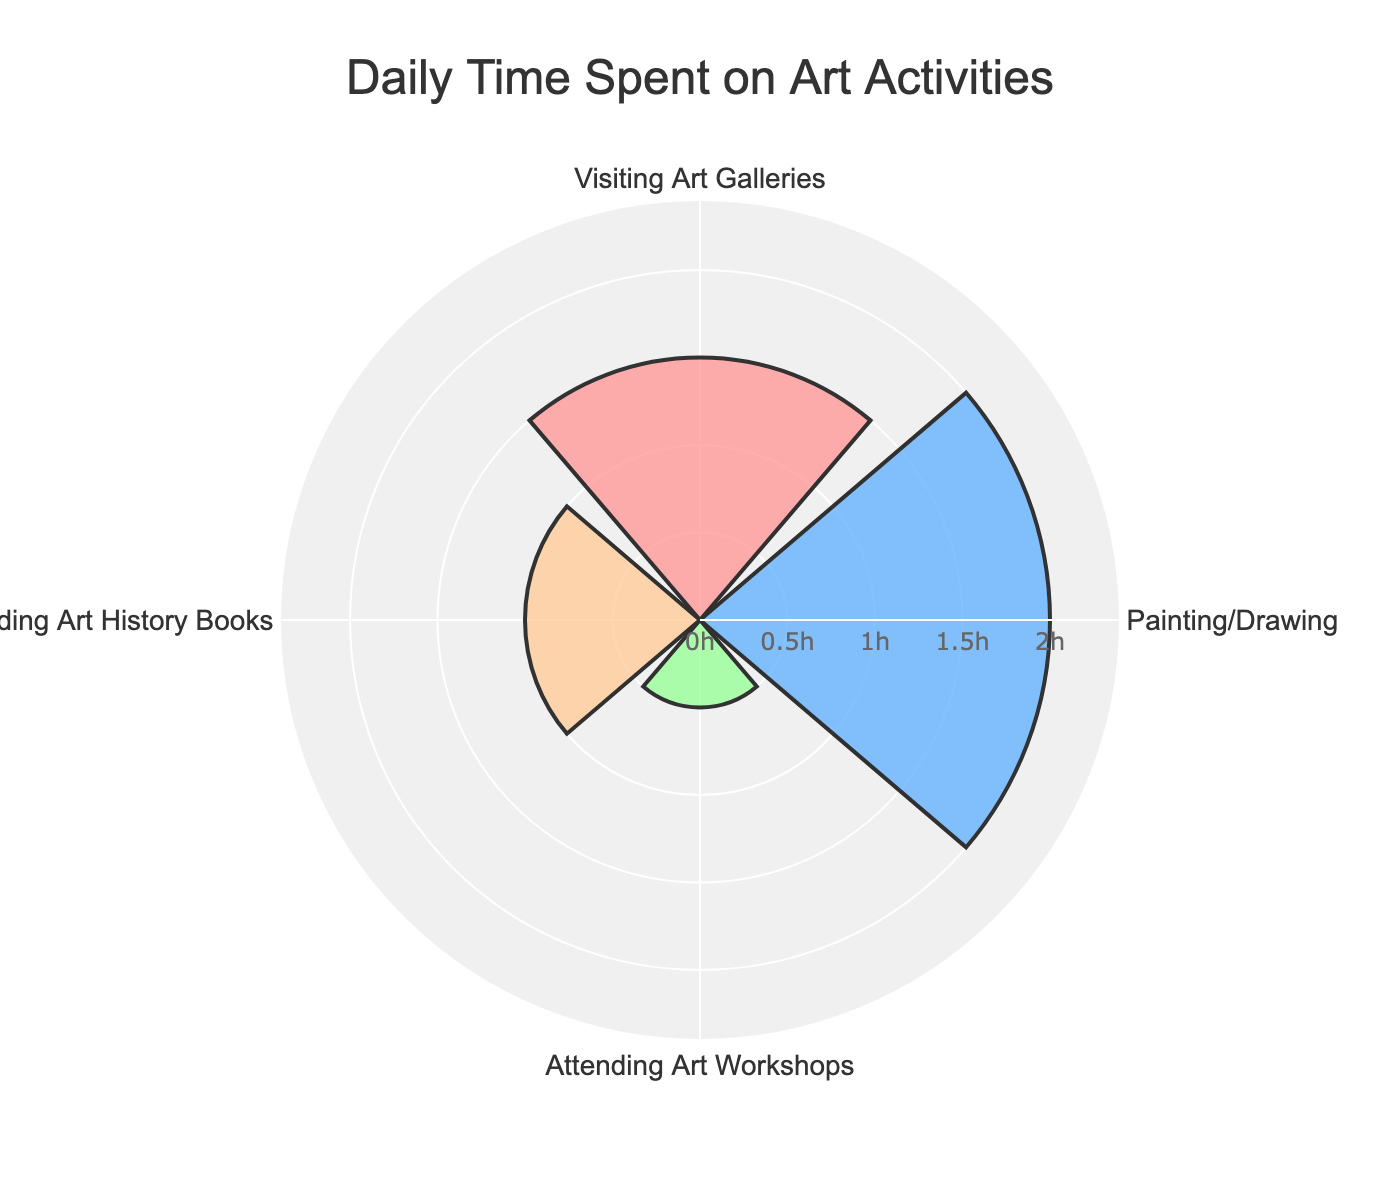What's the title of the chart? The title is usually found at the top of the figure. Here, it's clearly stated to provide an overview of what the chart represents.
Answer: Daily Time Spent on Art Activities What does the radial axis represent? The radial axis typically represents the value or magnitude of the data points. In this chart, it represents the time spent on various activities in hours.
Answer: Time spent in hours Which activity takes the most time daily? By examining the lengths of the bars, the longest bar indicates the activity with the most time spent. The longest bar corresponds to Painting/Drawing.
Answer: Painting/Drawing What’s the total time spent on all activities? To determine the total time spent, sum the times for all activities: 1.5 (Visiting Art Galleries) + 2 (Painting/Drawing) + 0.5 (Attending Art Workshops) + 1 (Reading Art History Books) = 5 hours.
Answer: 5 hours How much longer is the time spent on Painting/Drawing compared to Attending Art Workshops? Subtract the time spent on Attending Art Workshops from the time spent on Painting/Drawing: 2 hours (Painting/Drawing) - 0.5 hours (Attending Art Workshops) = 1.5 hours.
Answer: 1.5 hours What are the colors used to represent each activity? Observing the bars, each activity is represented by a distinct color: Visiting Art Galleries is pink, Painting/Drawing is blue, Attending Art Workshops is green, and Reading Art History Books is peach/orange.
Answer: Pink, Blue, Green, Peach/Orange How does the time spent on Reading Art History Books compare to Visiting Art Galleries? Compare the length of the bars representing these activities. Reading Art History Books and Visiting Art Galleries both have equal lengths, indicating they take the same time.
Answer: Equal time What’s the average time spent per activity? To find the average, sum up the time for all activities and divide by the number of activities: (1.5 + 2 + 0.5 + 1) / 4 = 5 / 4 = 1.25 hours.
Answer: 1.25 hours Which activity is represented by the green color? By directly referring to the color legend or matching the green bar to the activity, we find that the Attending Art Workshops activity is represented by green.
Answer: Attending Art Workshops If an amateur enthusiast decides to spend twice as much time on Art Workshops, how would it compare to the time spent on Painting/Drawing? Doubling the time for Attending Art Workshops: 0.5 * 2 = 1 hour. Compare this with Painting/Drawing: 1 hour (new time for workshops) vs. 2 hours (Painting/Drawing). Painting/Drawing still takes more time.
Answer: Painting/Drawing takes more time 